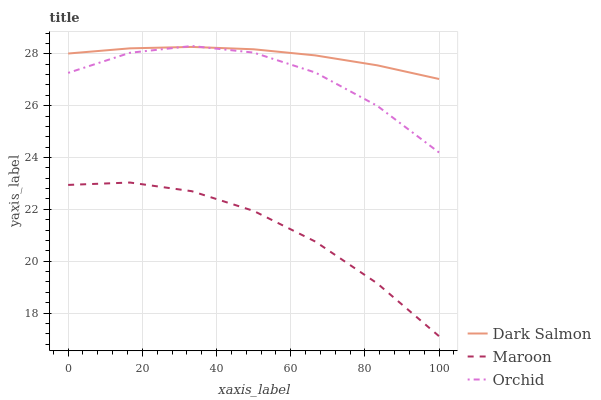Does Orchid have the minimum area under the curve?
Answer yes or no. No. Does Orchid have the maximum area under the curve?
Answer yes or no. No. Is Maroon the smoothest?
Answer yes or no. No. Is Maroon the roughest?
Answer yes or no. No. Does Orchid have the lowest value?
Answer yes or no. No. Does Maroon have the highest value?
Answer yes or no. No. Is Maroon less than Dark Salmon?
Answer yes or no. Yes. Is Orchid greater than Maroon?
Answer yes or no. Yes. Does Maroon intersect Dark Salmon?
Answer yes or no. No. 